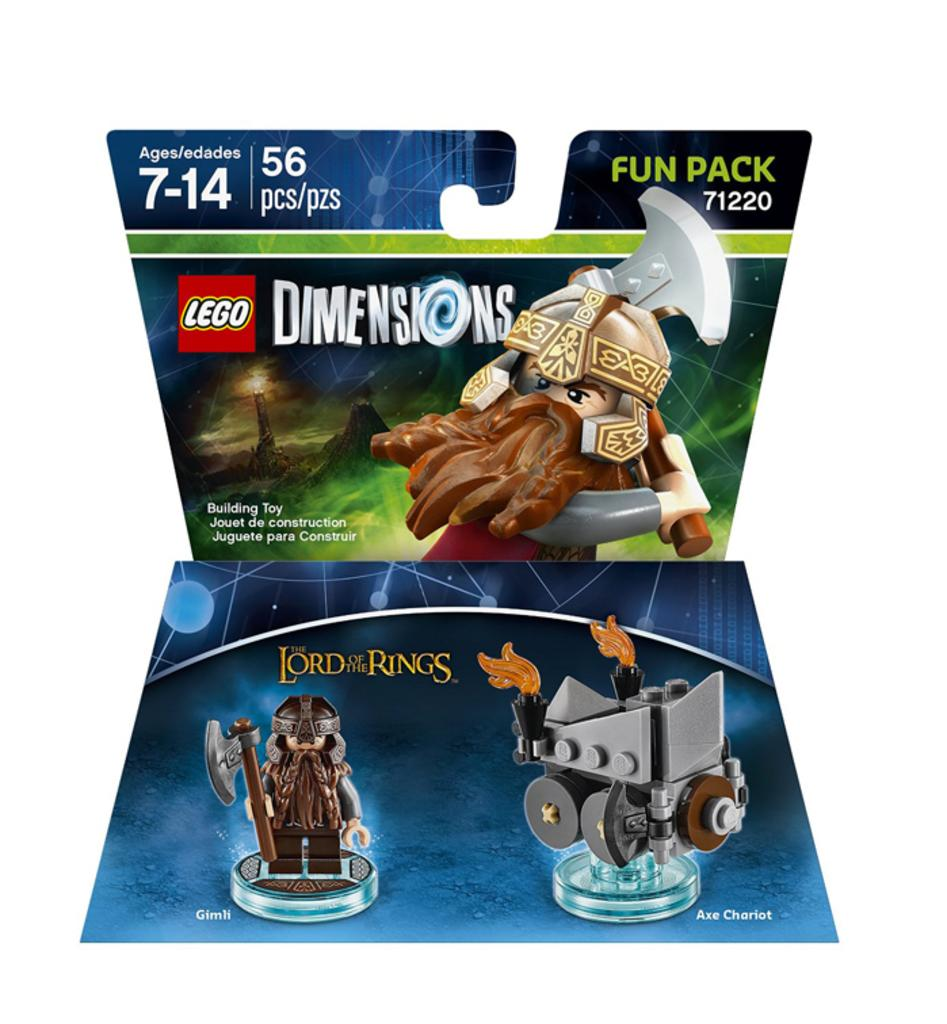How many posters are visible in the image? There are two posters in the image. What type of images are on the posters? The posters contain animated images. What else can be found on the posters besides the images? There is text on the posters. What is the color of the background in the image? The background color is white. Can you hear the bell ringing in the image? There is no bell present in the image, so it cannot be heard. Is there any indication of rain in the image? There is no mention of rain or any related elements in the image. 